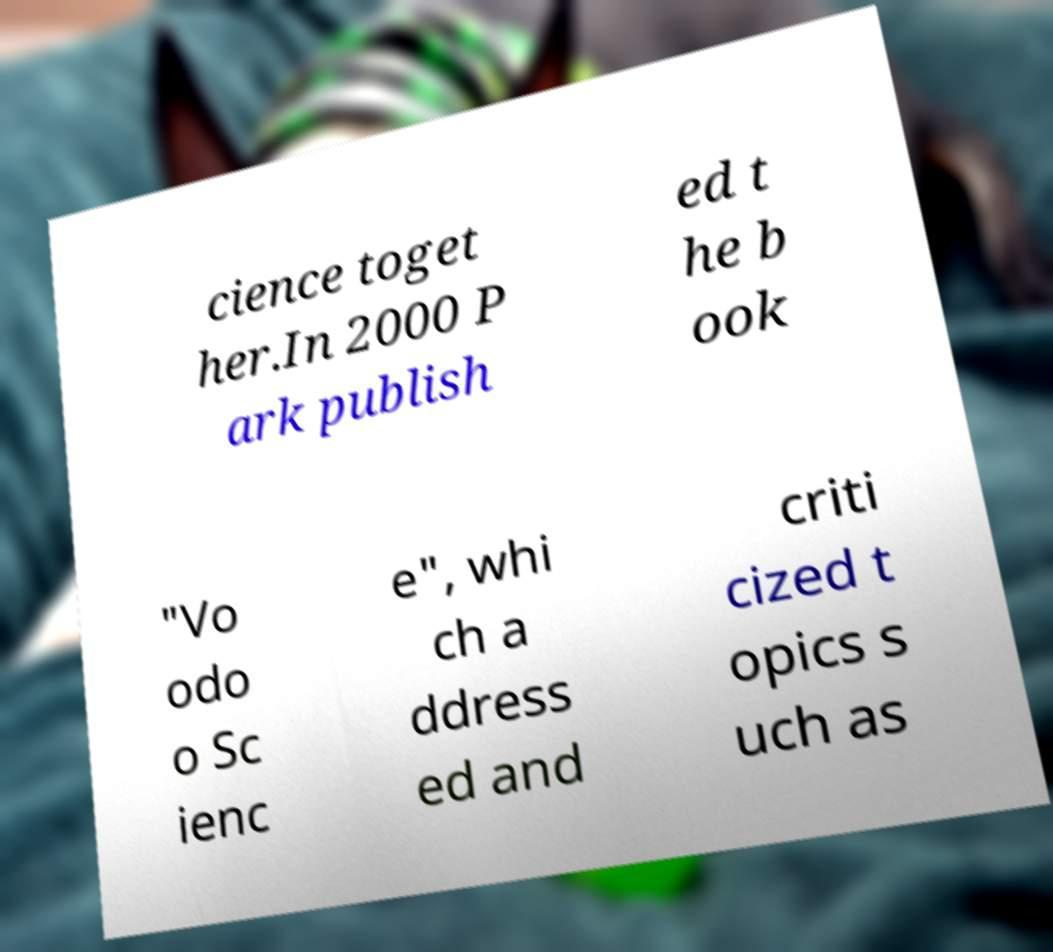What messages or text are displayed in this image? I need them in a readable, typed format. cience toget her.In 2000 P ark publish ed t he b ook "Vo odo o Sc ienc e", whi ch a ddress ed and criti cized t opics s uch as 